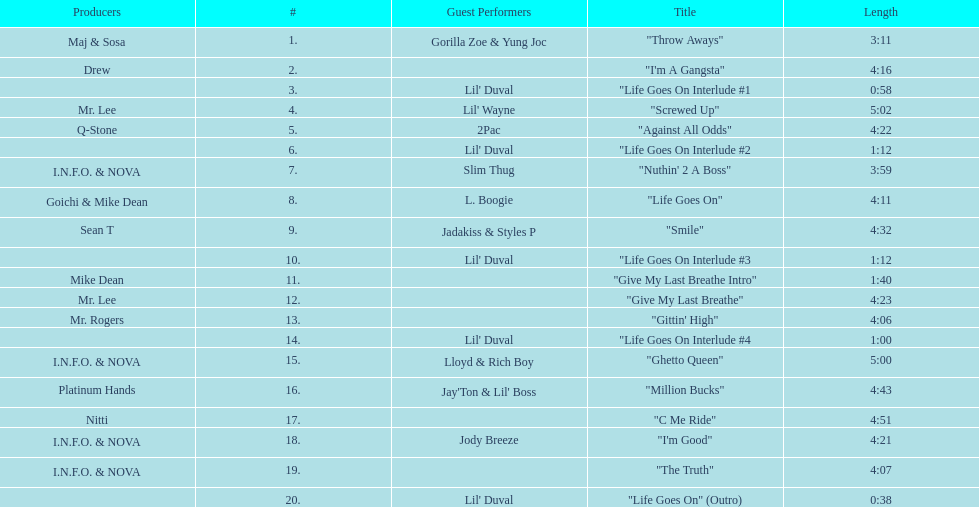How many tracks on trae's album "life goes on"? 20. Write the full table. {'header': ['Producers', '#', 'Guest Performers', 'Title', 'Length'], 'rows': [['Maj & Sosa', '1.', 'Gorilla Zoe & Yung Joc', '"Throw Aways"', '3:11'], ['Drew', '2.', '', '"I\'m A Gangsta"', '4:16'], ['', '3.', "Lil' Duval", '"Life Goes On Interlude #1', '0:58'], ['Mr. Lee', '4.', "Lil' Wayne", '"Screwed Up"', '5:02'], ['Q-Stone', '5.', '2Pac', '"Against All Odds"', '4:22'], ['', '6.', "Lil' Duval", '"Life Goes On Interlude #2', '1:12'], ['I.N.F.O. & NOVA', '7.', 'Slim Thug', '"Nuthin\' 2 A Boss"', '3:59'], ['Goichi & Mike Dean', '8.', 'L. Boogie', '"Life Goes On"', '4:11'], ['Sean T', '9.', 'Jadakiss & Styles P', '"Smile"', '4:32'], ['', '10.', "Lil' Duval", '"Life Goes On Interlude #3', '1:12'], ['Mike Dean', '11.', '', '"Give My Last Breathe Intro"', '1:40'], ['Mr. Lee', '12.', '', '"Give My Last Breathe"', '4:23'], ['Mr. Rogers', '13.', '', '"Gittin\' High"', '4:06'], ['', '14.', "Lil' Duval", '"Life Goes On Interlude #4', '1:00'], ['I.N.F.O. & NOVA', '15.', 'Lloyd & Rich Boy', '"Ghetto Queen"', '5:00'], ['Platinum Hands', '16.', "Jay'Ton & Lil' Boss", '"Million Bucks"', '4:43'], ['Nitti', '17.', '', '"C Me Ride"', '4:51'], ['I.N.F.O. & NOVA', '18.', 'Jody Breeze', '"I\'m Good"', '4:21'], ['I.N.F.O. & NOVA', '19.', '', '"The Truth"', '4:07'], ['', '20.', "Lil' Duval", '"Life Goes On" (Outro)', '0:38']]} 